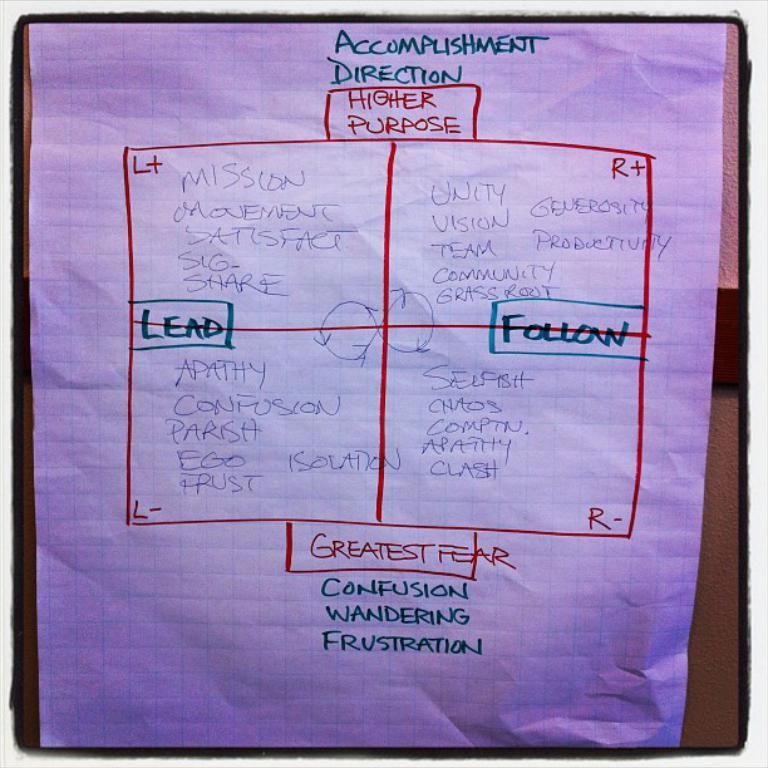<image>
Provide a brief description of the given image. A white big piece of paper that is an accomplishment direction 